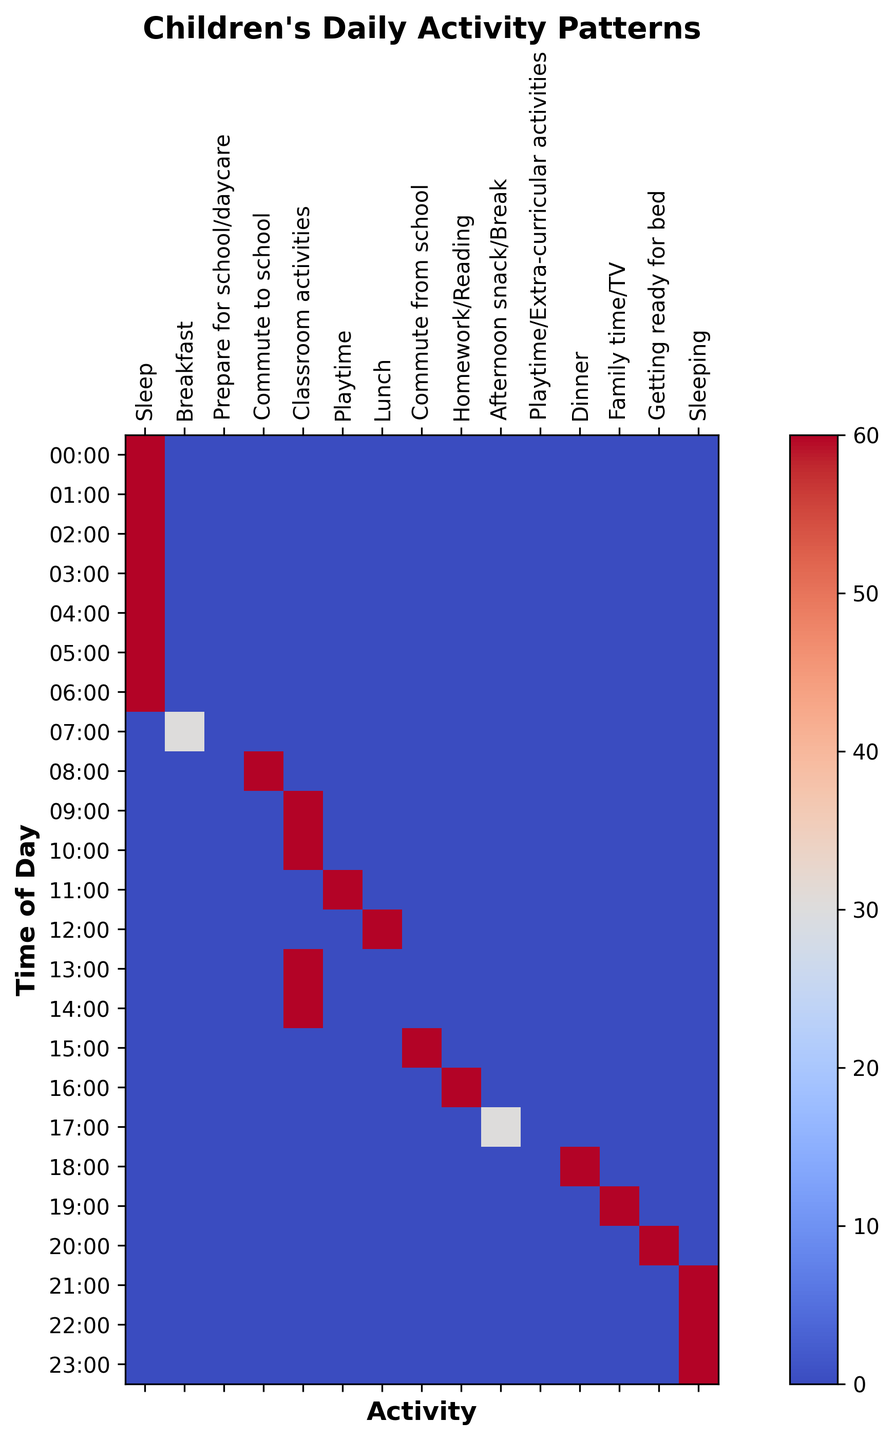What is the most common activity from 9 AM to 3 PM? The figure shows the heatmap with different activities. Look for the hours between 9 AM to 3 PM and identify the activity with the highest frequency or presence. Classroom activities dominate most of these hours.
Answer: Classroom activities How does the duration of sleep compare to the duration of classroom activities? Sum the duration of sleep and the duration of classroom activities from the figure. Sleep is from 9 PM to 7 AM (10 hours), and classroom activities occur from 9 AM to 3 PM (6 hours).
Answer: Sleep is longer Are there more minutes spent on breakfast or dinner per day? Check the duration columns for breakfast and dinner. Breakfast is for 30 minutes, while dinner is for 60 minutes.
Answer: Dinner Which activity duration is the smallest throughout the day? Look for the activity in the heatmap that occupies the smallest slots. Breakfast occupies the smallest slot of 30 minutes.
Answer: Breakfast What activities are conducted during the time of 5 PM to 6 PM? Check the heatmap and identify the activities during the given time slot. 5 PM to 6 PM includes Homework/Reading and Afternoon snack/Break.
Answer: Homework/Reading and Afternoon snack/Break What is the total duration of playtime and extracurricular activities throughout the entire day? Add up all time slots labeled Playtime and Playtime/Extra-curricular activities. Playtime is 1 hour from 11 AM to 12 PM, and Playtime/Extra-curricular activities are from 5:30 PM to 6:30 PM, summing to 2 hours.
Answer: 2 hours Does the figure show more time spent commuting to or from school? Compare the slots for commuting to school (8 AM to 9 AM) and commuting from school (3 PM to 4 PM). Both have 1-hour slots.
Answer: Equal time 